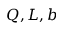<formula> <loc_0><loc_0><loc_500><loc_500>Q , L , b</formula> 